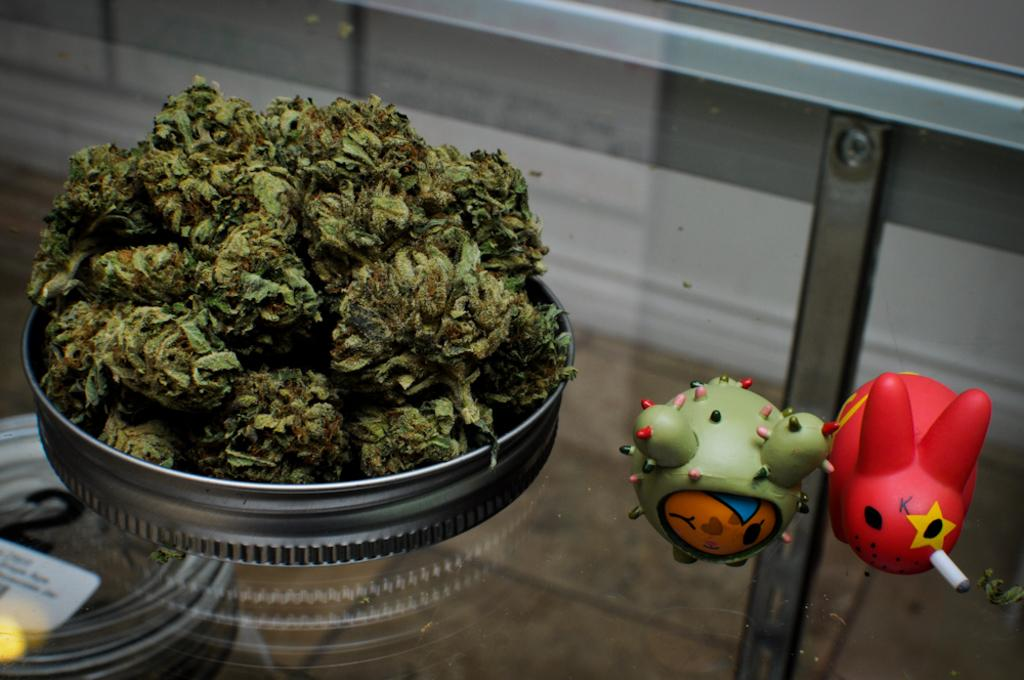What is in the bowl that is visible in the image? There is food in a bowl in the image. Besides the food, what other items can be seen in the image? There are toys visible in the image. Where are the food and toys located in the image? The food and toys are on a glass platform. What type of game is being played on the glass platform in the image? There is no game being played on the glass platform in the image; it only contains food in a bowl and toys. 